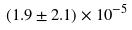Convert formula to latex. <formula><loc_0><loc_0><loc_500><loc_500>( 1 . 9 \pm 2 . 1 ) \times 1 0 ^ { - 5 }</formula> 